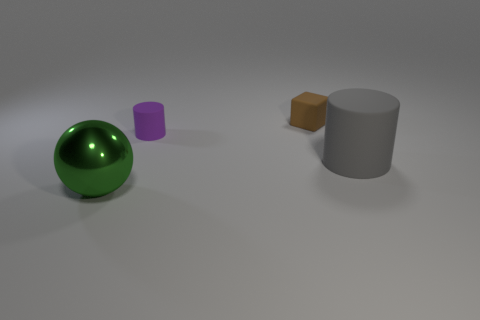Add 3 matte cylinders. How many objects exist? 7 Subtract all gray cylinders. How many cylinders are left? 1 Subtract all blocks. How many objects are left? 3 Subtract 0 cyan cylinders. How many objects are left? 4 Subtract all red blocks. Subtract all gray cylinders. How many blocks are left? 1 Subtract all matte blocks. Subtract all large metal objects. How many objects are left? 2 Add 3 small brown blocks. How many small brown blocks are left? 4 Add 3 green metal spheres. How many green metal spheres exist? 4 